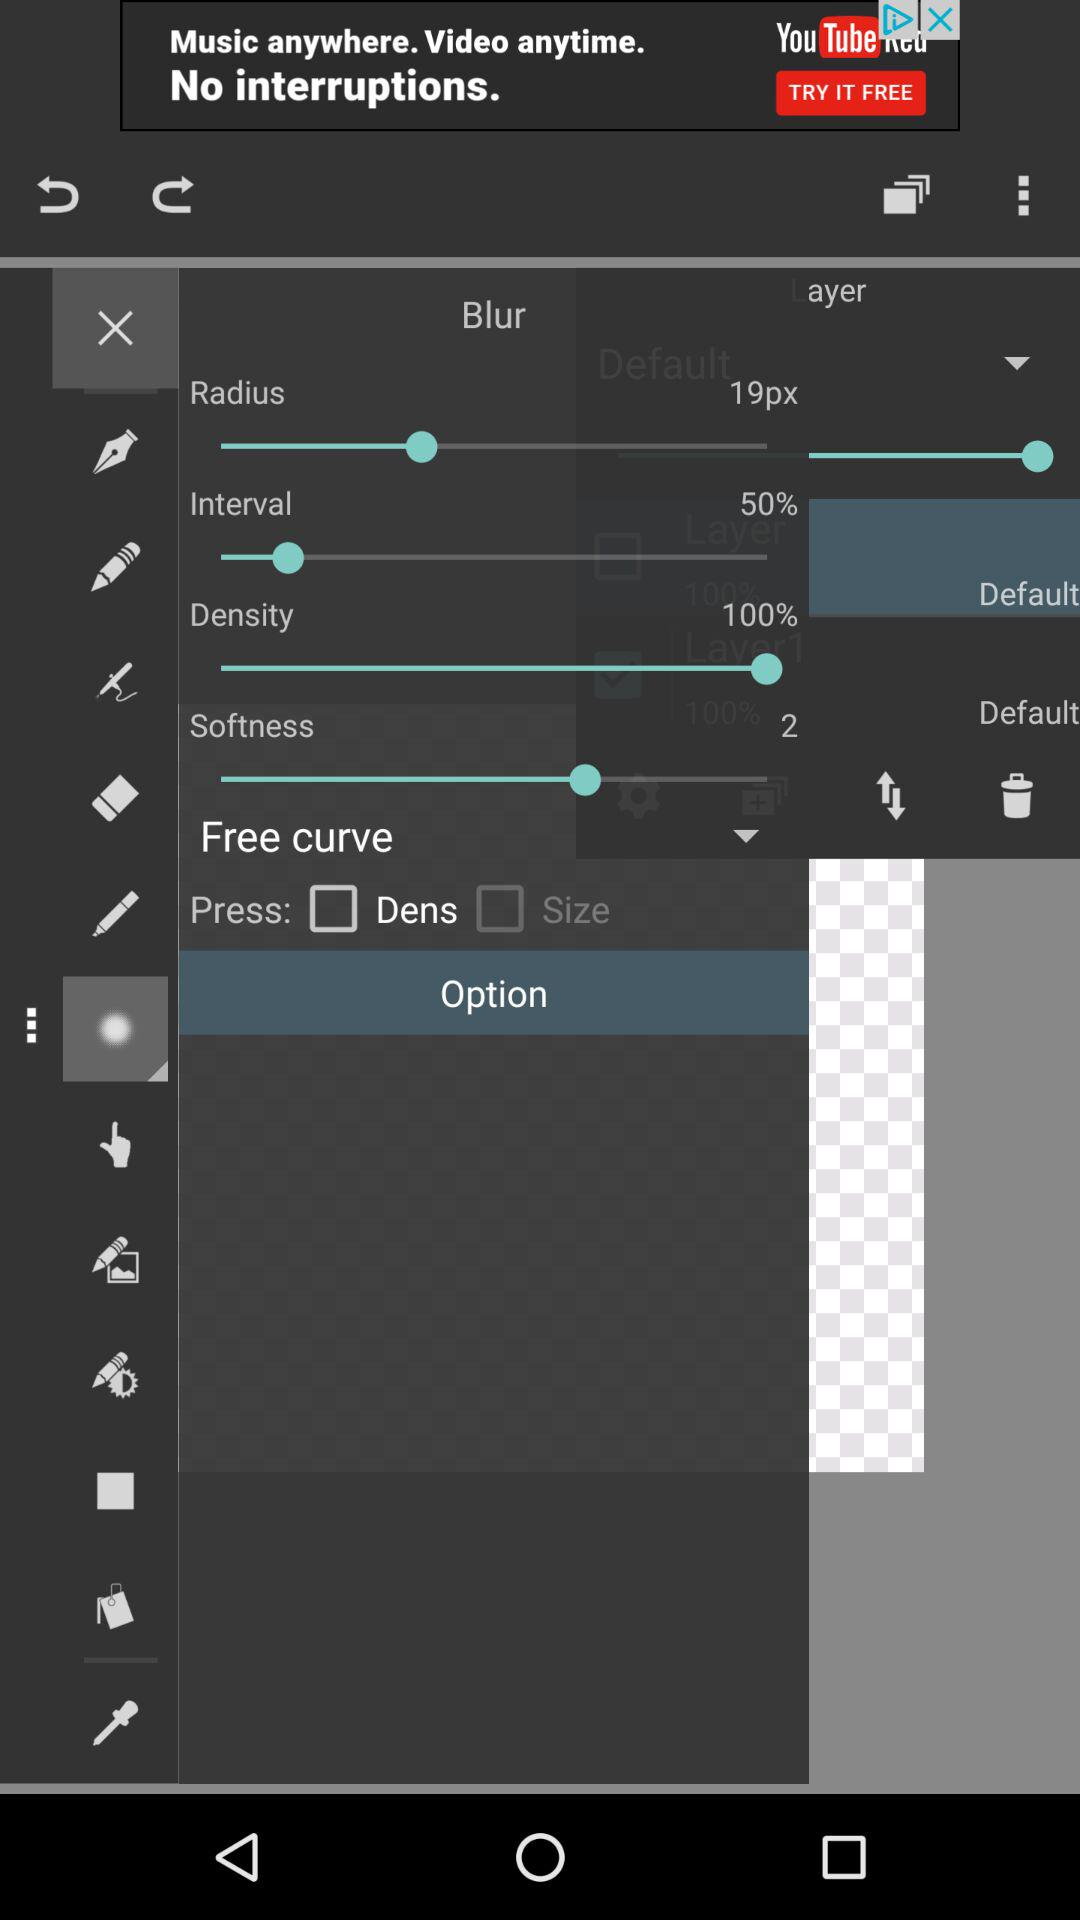What value is set for the softness? The set value is 2. 